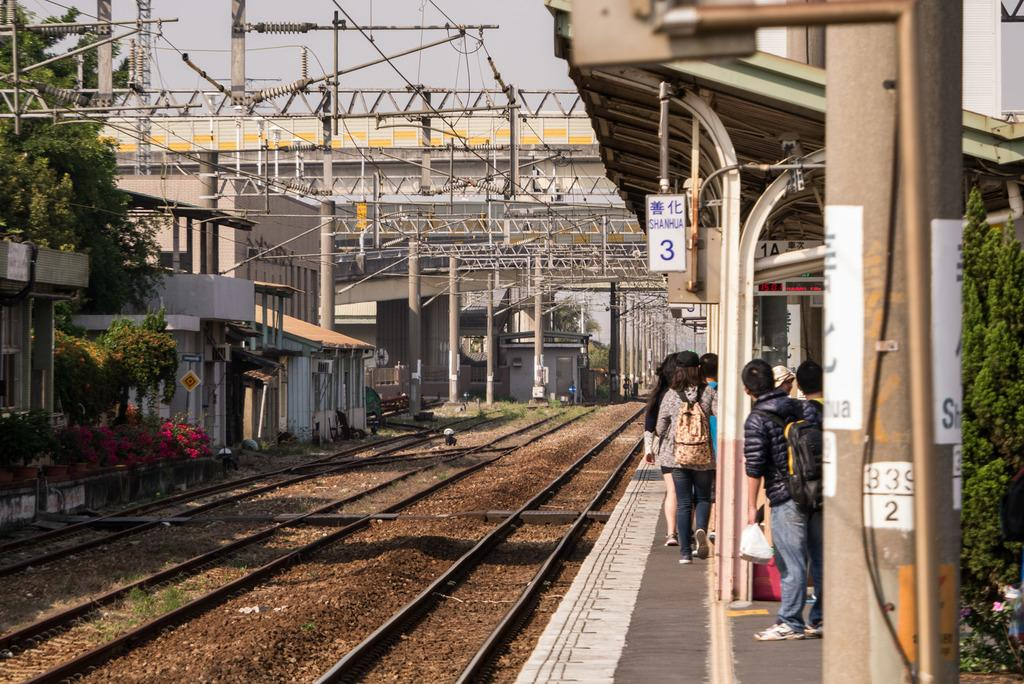What is the main feature of the image? There is a railway track in the image. Are there any people in the image? Yes, there is a group of persons standing near the railway track. What else can be seen in the image besides the railway track and people? There is a pole, trees, flowers, and the sky is visible in the image. What arithmetic problem are the people solving in the image? There is no indication in the image that the people are solving an arithmetic problem. How does the railway track respond to the earthquake in the image? There is no earthquake present in the image, so the railway track's response cannot be determined. 